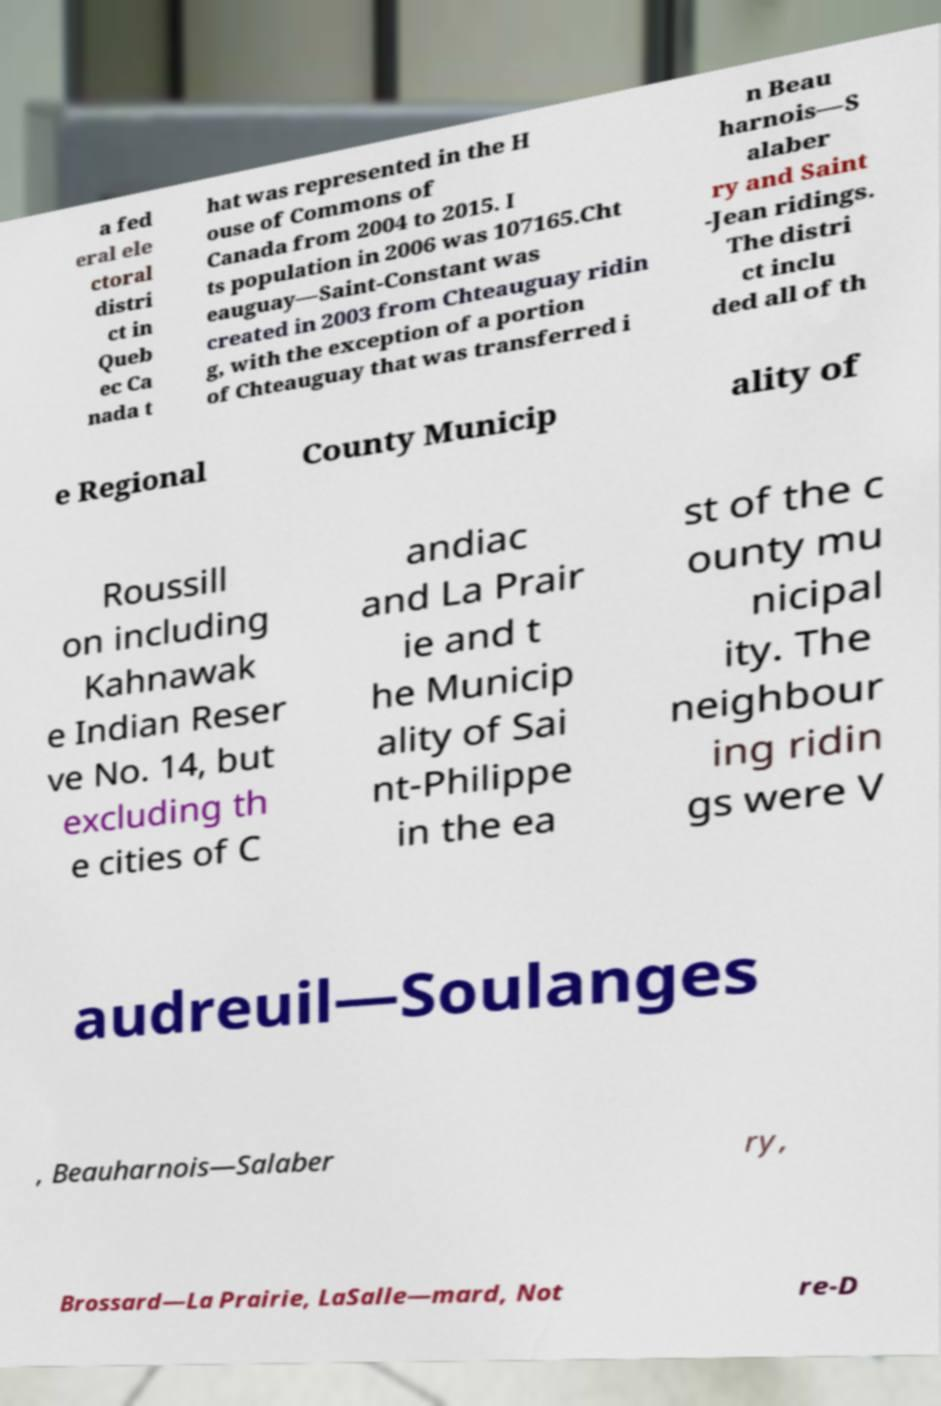What messages or text are displayed in this image? I need them in a readable, typed format. a fed eral ele ctoral distri ct in Queb ec Ca nada t hat was represented in the H ouse of Commons of Canada from 2004 to 2015. I ts population in 2006 was 107165.Cht eauguay—Saint-Constant was created in 2003 from Chteauguay ridin g, with the exception of a portion of Chteauguay that was transferred i n Beau harnois—S alaber ry and Saint -Jean ridings. The distri ct inclu ded all of th e Regional County Municip ality of Roussill on including Kahnawak e Indian Reser ve No. 14, but excluding th e cities of C andiac and La Prair ie and t he Municip ality of Sai nt-Philippe in the ea st of the c ounty mu nicipal ity. The neighbour ing ridin gs were V audreuil—Soulanges , Beauharnois—Salaber ry, Brossard—La Prairie, LaSalle—mard, Not re-D 